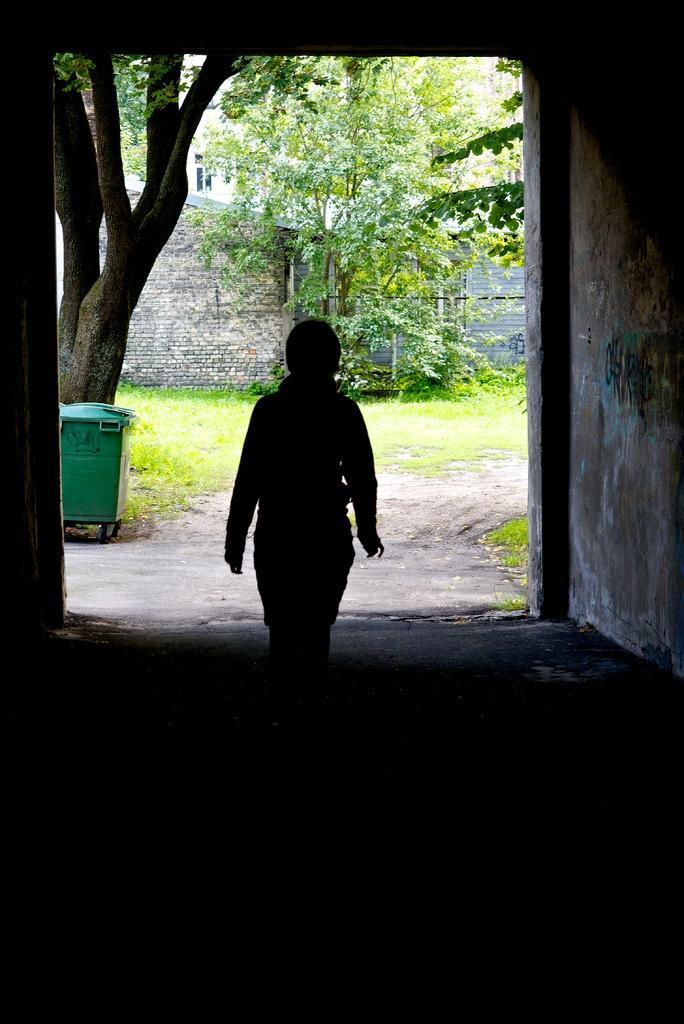Describe this image in one or two sentences. This picture is inside view of a room. In the center of the image a person is standing. In the background of the image we can see a building, wall, plants are there. On the left side of the image garbage bin is present. In the middle of the image grass is there. At the bottom of the image floor is present. 